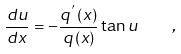Convert formula to latex. <formula><loc_0><loc_0><loc_500><loc_500>\frac { d u } { d x } = - \frac { q ^ { ^ { \prime } } \left ( x \right ) } { q \left ( x \right ) } \tan u \quad ,</formula> 